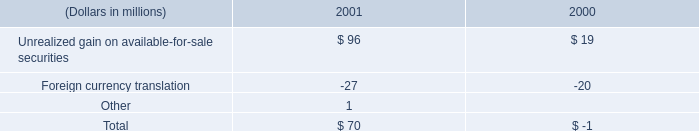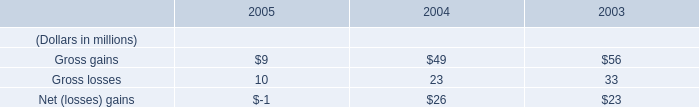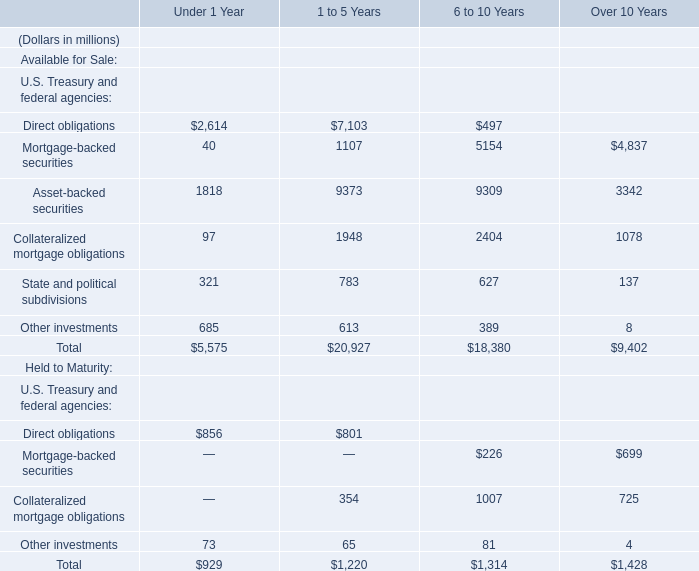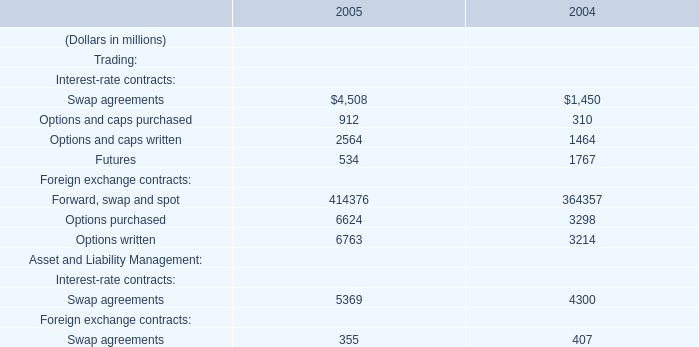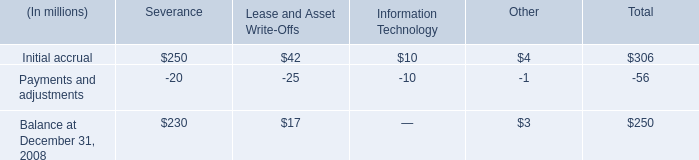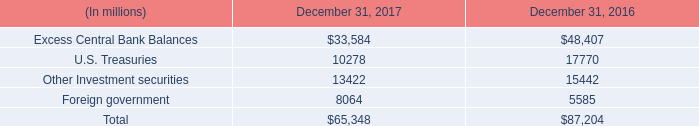between 2000 and 2001 , what was the percent increase of unrealized gains? 
Computations: ((96 - 19) / 19)
Answer: 4.05263. 